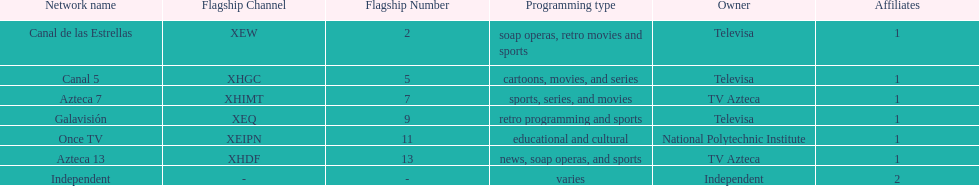What is the only network owned by national polytechnic institute? Once TV. 